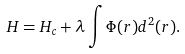<formula> <loc_0><loc_0><loc_500><loc_500>H = H _ { c } + \lambda \int \Phi ( r ) d ^ { 2 } ( r ) .</formula> 